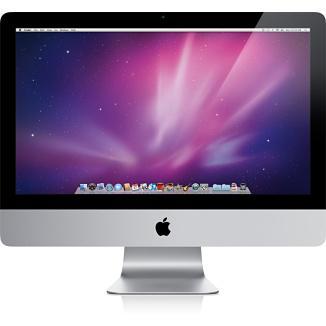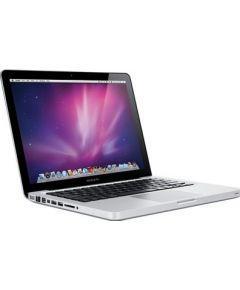The first image is the image on the left, the second image is the image on the right. Assess this claim about the two images: "Each image contains one device displayed so the screen is visible, and each screen has the same glowing violet and blue picture on it.". Correct or not? Answer yes or no. Yes. The first image is the image on the left, the second image is the image on the right. Analyze the images presented: Is the assertion "The left and right image contains the same number of fully open laptops." valid? Answer yes or no. No. 